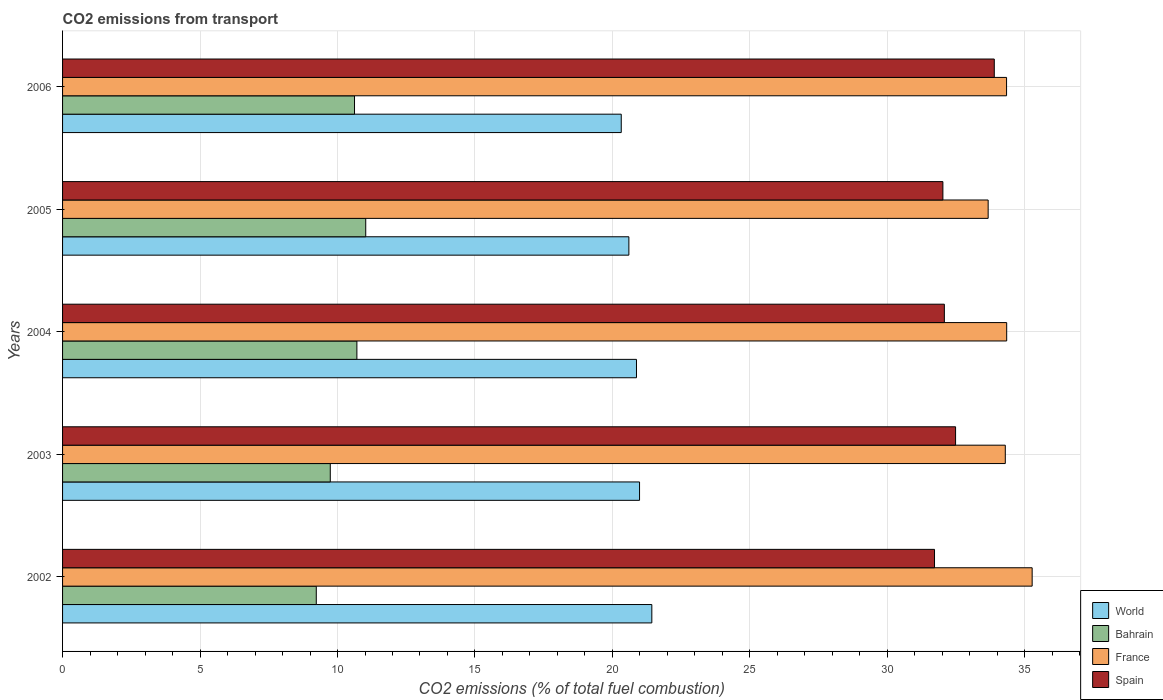How many different coloured bars are there?
Keep it short and to the point. 4. Are the number of bars per tick equal to the number of legend labels?
Make the answer very short. Yes. Are the number of bars on each tick of the Y-axis equal?
Offer a terse response. Yes. How many bars are there on the 2nd tick from the bottom?
Ensure brevity in your answer.  4. What is the total CO2 emitted in World in 2002?
Give a very brief answer. 21.43. Across all years, what is the maximum total CO2 emitted in France?
Offer a very short reply. 35.27. Across all years, what is the minimum total CO2 emitted in Spain?
Provide a short and direct response. 31.71. In which year was the total CO2 emitted in World minimum?
Provide a succinct answer. 2006. What is the total total CO2 emitted in Spain in the graph?
Provide a short and direct response. 162.18. What is the difference between the total CO2 emitted in World in 2004 and that in 2005?
Your answer should be compact. 0.28. What is the difference between the total CO2 emitted in Bahrain in 2006 and the total CO2 emitted in France in 2003?
Your answer should be compact. -23.67. What is the average total CO2 emitted in World per year?
Offer a terse response. 20.84. In the year 2003, what is the difference between the total CO2 emitted in World and total CO2 emitted in Spain?
Make the answer very short. -11.49. In how many years, is the total CO2 emitted in Spain greater than 14 ?
Give a very brief answer. 5. What is the ratio of the total CO2 emitted in Spain in 2002 to that in 2003?
Provide a succinct answer. 0.98. Is the difference between the total CO2 emitted in World in 2002 and 2006 greater than the difference between the total CO2 emitted in Spain in 2002 and 2006?
Offer a terse response. Yes. What is the difference between the highest and the second highest total CO2 emitted in France?
Give a very brief answer. 0.93. What is the difference between the highest and the lowest total CO2 emitted in Spain?
Your answer should be compact. 2.17. In how many years, is the total CO2 emitted in Bahrain greater than the average total CO2 emitted in Bahrain taken over all years?
Ensure brevity in your answer.  3. Is it the case that in every year, the sum of the total CO2 emitted in France and total CO2 emitted in Bahrain is greater than the sum of total CO2 emitted in Spain and total CO2 emitted in World?
Your answer should be very brief. No. What does the 4th bar from the top in 2006 represents?
Offer a very short reply. World. What does the 4th bar from the bottom in 2003 represents?
Your response must be concise. Spain. How many bars are there?
Make the answer very short. 20. How many years are there in the graph?
Provide a succinct answer. 5. What is the difference between two consecutive major ticks on the X-axis?
Provide a short and direct response. 5. Does the graph contain grids?
Your answer should be compact. Yes. How many legend labels are there?
Your answer should be very brief. 4. How are the legend labels stacked?
Provide a short and direct response. Vertical. What is the title of the graph?
Offer a very short reply. CO2 emissions from transport. What is the label or title of the X-axis?
Offer a terse response. CO2 emissions (% of total fuel combustion). What is the label or title of the Y-axis?
Make the answer very short. Years. What is the CO2 emissions (% of total fuel combustion) of World in 2002?
Your response must be concise. 21.43. What is the CO2 emissions (% of total fuel combustion) of Bahrain in 2002?
Your answer should be compact. 9.23. What is the CO2 emissions (% of total fuel combustion) in France in 2002?
Your answer should be very brief. 35.27. What is the CO2 emissions (% of total fuel combustion) of Spain in 2002?
Provide a short and direct response. 31.71. What is the CO2 emissions (% of total fuel combustion) in World in 2003?
Offer a very short reply. 20.99. What is the CO2 emissions (% of total fuel combustion) in Bahrain in 2003?
Your answer should be very brief. 9.74. What is the CO2 emissions (% of total fuel combustion) of France in 2003?
Offer a terse response. 34.29. What is the CO2 emissions (% of total fuel combustion) in Spain in 2003?
Keep it short and to the point. 32.48. What is the CO2 emissions (% of total fuel combustion) in World in 2004?
Offer a terse response. 20.87. What is the CO2 emissions (% of total fuel combustion) in Bahrain in 2004?
Your response must be concise. 10.71. What is the CO2 emissions (% of total fuel combustion) in France in 2004?
Your response must be concise. 34.34. What is the CO2 emissions (% of total fuel combustion) of Spain in 2004?
Provide a short and direct response. 32.07. What is the CO2 emissions (% of total fuel combustion) of World in 2005?
Make the answer very short. 20.6. What is the CO2 emissions (% of total fuel combustion) of Bahrain in 2005?
Ensure brevity in your answer.  11.03. What is the CO2 emissions (% of total fuel combustion) in France in 2005?
Provide a short and direct response. 33.67. What is the CO2 emissions (% of total fuel combustion) in Spain in 2005?
Make the answer very short. 32.02. What is the CO2 emissions (% of total fuel combustion) in World in 2006?
Your answer should be compact. 20.32. What is the CO2 emissions (% of total fuel combustion) of Bahrain in 2006?
Your response must be concise. 10.62. What is the CO2 emissions (% of total fuel combustion) in France in 2006?
Provide a succinct answer. 34.34. What is the CO2 emissions (% of total fuel combustion) of Spain in 2006?
Ensure brevity in your answer.  33.89. Across all years, what is the maximum CO2 emissions (% of total fuel combustion) in World?
Ensure brevity in your answer.  21.43. Across all years, what is the maximum CO2 emissions (% of total fuel combustion) of Bahrain?
Offer a terse response. 11.03. Across all years, what is the maximum CO2 emissions (% of total fuel combustion) in France?
Make the answer very short. 35.27. Across all years, what is the maximum CO2 emissions (% of total fuel combustion) of Spain?
Provide a short and direct response. 33.89. Across all years, what is the minimum CO2 emissions (% of total fuel combustion) of World?
Make the answer very short. 20.32. Across all years, what is the minimum CO2 emissions (% of total fuel combustion) of Bahrain?
Your answer should be very brief. 9.23. Across all years, what is the minimum CO2 emissions (% of total fuel combustion) in France?
Make the answer very short. 33.67. Across all years, what is the minimum CO2 emissions (% of total fuel combustion) in Spain?
Your response must be concise. 31.71. What is the total CO2 emissions (% of total fuel combustion) of World in the graph?
Your answer should be very brief. 104.21. What is the total CO2 emissions (% of total fuel combustion) in Bahrain in the graph?
Make the answer very short. 51.32. What is the total CO2 emissions (% of total fuel combustion) in France in the graph?
Make the answer very short. 171.9. What is the total CO2 emissions (% of total fuel combustion) of Spain in the graph?
Give a very brief answer. 162.18. What is the difference between the CO2 emissions (% of total fuel combustion) of World in 2002 and that in 2003?
Provide a short and direct response. 0.45. What is the difference between the CO2 emissions (% of total fuel combustion) of Bahrain in 2002 and that in 2003?
Keep it short and to the point. -0.51. What is the difference between the CO2 emissions (% of total fuel combustion) in France in 2002 and that in 2003?
Offer a very short reply. 0.98. What is the difference between the CO2 emissions (% of total fuel combustion) of Spain in 2002 and that in 2003?
Make the answer very short. -0.77. What is the difference between the CO2 emissions (% of total fuel combustion) of World in 2002 and that in 2004?
Give a very brief answer. 0.56. What is the difference between the CO2 emissions (% of total fuel combustion) of Bahrain in 2002 and that in 2004?
Provide a succinct answer. -1.48. What is the difference between the CO2 emissions (% of total fuel combustion) of France in 2002 and that in 2004?
Your answer should be very brief. 0.93. What is the difference between the CO2 emissions (% of total fuel combustion) in Spain in 2002 and that in 2004?
Offer a terse response. -0.36. What is the difference between the CO2 emissions (% of total fuel combustion) in World in 2002 and that in 2005?
Provide a succinct answer. 0.83. What is the difference between the CO2 emissions (% of total fuel combustion) in Bahrain in 2002 and that in 2005?
Make the answer very short. -1.8. What is the difference between the CO2 emissions (% of total fuel combustion) in France in 2002 and that in 2005?
Offer a terse response. 1.6. What is the difference between the CO2 emissions (% of total fuel combustion) of Spain in 2002 and that in 2005?
Keep it short and to the point. -0.3. What is the difference between the CO2 emissions (% of total fuel combustion) in World in 2002 and that in 2006?
Provide a short and direct response. 1.11. What is the difference between the CO2 emissions (% of total fuel combustion) in Bahrain in 2002 and that in 2006?
Offer a terse response. -1.39. What is the difference between the CO2 emissions (% of total fuel combustion) in France in 2002 and that in 2006?
Provide a succinct answer. 0.93. What is the difference between the CO2 emissions (% of total fuel combustion) of Spain in 2002 and that in 2006?
Provide a short and direct response. -2.17. What is the difference between the CO2 emissions (% of total fuel combustion) in World in 2003 and that in 2004?
Give a very brief answer. 0.11. What is the difference between the CO2 emissions (% of total fuel combustion) in Bahrain in 2003 and that in 2004?
Keep it short and to the point. -0.97. What is the difference between the CO2 emissions (% of total fuel combustion) in France in 2003 and that in 2004?
Offer a terse response. -0.05. What is the difference between the CO2 emissions (% of total fuel combustion) in Spain in 2003 and that in 2004?
Provide a short and direct response. 0.41. What is the difference between the CO2 emissions (% of total fuel combustion) of World in 2003 and that in 2005?
Provide a succinct answer. 0.39. What is the difference between the CO2 emissions (% of total fuel combustion) of Bahrain in 2003 and that in 2005?
Provide a succinct answer. -1.29. What is the difference between the CO2 emissions (% of total fuel combustion) in France in 2003 and that in 2005?
Offer a very short reply. 0.62. What is the difference between the CO2 emissions (% of total fuel combustion) of Spain in 2003 and that in 2005?
Keep it short and to the point. 0.46. What is the difference between the CO2 emissions (% of total fuel combustion) of World in 2003 and that in 2006?
Your answer should be compact. 0.67. What is the difference between the CO2 emissions (% of total fuel combustion) in Bahrain in 2003 and that in 2006?
Ensure brevity in your answer.  -0.88. What is the difference between the CO2 emissions (% of total fuel combustion) in France in 2003 and that in 2006?
Make the answer very short. -0.05. What is the difference between the CO2 emissions (% of total fuel combustion) in Spain in 2003 and that in 2006?
Give a very brief answer. -1.41. What is the difference between the CO2 emissions (% of total fuel combustion) in World in 2004 and that in 2005?
Offer a very short reply. 0.28. What is the difference between the CO2 emissions (% of total fuel combustion) of Bahrain in 2004 and that in 2005?
Ensure brevity in your answer.  -0.32. What is the difference between the CO2 emissions (% of total fuel combustion) of France in 2004 and that in 2005?
Provide a short and direct response. 0.67. What is the difference between the CO2 emissions (% of total fuel combustion) in Spain in 2004 and that in 2005?
Your answer should be compact. 0.05. What is the difference between the CO2 emissions (% of total fuel combustion) of World in 2004 and that in 2006?
Provide a succinct answer. 0.55. What is the difference between the CO2 emissions (% of total fuel combustion) in Bahrain in 2004 and that in 2006?
Keep it short and to the point. 0.09. What is the difference between the CO2 emissions (% of total fuel combustion) in France in 2004 and that in 2006?
Ensure brevity in your answer.  0. What is the difference between the CO2 emissions (% of total fuel combustion) in Spain in 2004 and that in 2006?
Ensure brevity in your answer.  -1.82. What is the difference between the CO2 emissions (% of total fuel combustion) in World in 2005 and that in 2006?
Make the answer very short. 0.28. What is the difference between the CO2 emissions (% of total fuel combustion) of Bahrain in 2005 and that in 2006?
Offer a very short reply. 0.41. What is the difference between the CO2 emissions (% of total fuel combustion) in France in 2005 and that in 2006?
Your response must be concise. -0.67. What is the difference between the CO2 emissions (% of total fuel combustion) of Spain in 2005 and that in 2006?
Keep it short and to the point. -1.87. What is the difference between the CO2 emissions (% of total fuel combustion) of World in 2002 and the CO2 emissions (% of total fuel combustion) of Bahrain in 2003?
Offer a very short reply. 11.7. What is the difference between the CO2 emissions (% of total fuel combustion) in World in 2002 and the CO2 emissions (% of total fuel combustion) in France in 2003?
Ensure brevity in your answer.  -12.86. What is the difference between the CO2 emissions (% of total fuel combustion) in World in 2002 and the CO2 emissions (% of total fuel combustion) in Spain in 2003?
Your answer should be very brief. -11.05. What is the difference between the CO2 emissions (% of total fuel combustion) in Bahrain in 2002 and the CO2 emissions (% of total fuel combustion) in France in 2003?
Provide a succinct answer. -25.06. What is the difference between the CO2 emissions (% of total fuel combustion) of Bahrain in 2002 and the CO2 emissions (% of total fuel combustion) of Spain in 2003?
Provide a succinct answer. -23.25. What is the difference between the CO2 emissions (% of total fuel combustion) in France in 2002 and the CO2 emissions (% of total fuel combustion) in Spain in 2003?
Provide a succinct answer. 2.79. What is the difference between the CO2 emissions (% of total fuel combustion) of World in 2002 and the CO2 emissions (% of total fuel combustion) of Bahrain in 2004?
Provide a short and direct response. 10.73. What is the difference between the CO2 emissions (% of total fuel combustion) of World in 2002 and the CO2 emissions (% of total fuel combustion) of France in 2004?
Offer a very short reply. -12.91. What is the difference between the CO2 emissions (% of total fuel combustion) of World in 2002 and the CO2 emissions (% of total fuel combustion) of Spain in 2004?
Your response must be concise. -10.64. What is the difference between the CO2 emissions (% of total fuel combustion) in Bahrain in 2002 and the CO2 emissions (% of total fuel combustion) in France in 2004?
Make the answer very short. -25.11. What is the difference between the CO2 emissions (% of total fuel combustion) of Bahrain in 2002 and the CO2 emissions (% of total fuel combustion) of Spain in 2004?
Make the answer very short. -22.84. What is the difference between the CO2 emissions (% of total fuel combustion) of France in 2002 and the CO2 emissions (% of total fuel combustion) of Spain in 2004?
Provide a short and direct response. 3.19. What is the difference between the CO2 emissions (% of total fuel combustion) in World in 2002 and the CO2 emissions (% of total fuel combustion) in Bahrain in 2005?
Give a very brief answer. 10.41. What is the difference between the CO2 emissions (% of total fuel combustion) in World in 2002 and the CO2 emissions (% of total fuel combustion) in France in 2005?
Provide a succinct answer. -12.23. What is the difference between the CO2 emissions (% of total fuel combustion) in World in 2002 and the CO2 emissions (% of total fuel combustion) in Spain in 2005?
Make the answer very short. -10.59. What is the difference between the CO2 emissions (% of total fuel combustion) of Bahrain in 2002 and the CO2 emissions (% of total fuel combustion) of France in 2005?
Offer a terse response. -24.44. What is the difference between the CO2 emissions (% of total fuel combustion) in Bahrain in 2002 and the CO2 emissions (% of total fuel combustion) in Spain in 2005?
Keep it short and to the point. -22.79. What is the difference between the CO2 emissions (% of total fuel combustion) of France in 2002 and the CO2 emissions (% of total fuel combustion) of Spain in 2005?
Provide a succinct answer. 3.25. What is the difference between the CO2 emissions (% of total fuel combustion) of World in 2002 and the CO2 emissions (% of total fuel combustion) of Bahrain in 2006?
Provide a succinct answer. 10.81. What is the difference between the CO2 emissions (% of total fuel combustion) in World in 2002 and the CO2 emissions (% of total fuel combustion) in France in 2006?
Give a very brief answer. -12.9. What is the difference between the CO2 emissions (% of total fuel combustion) of World in 2002 and the CO2 emissions (% of total fuel combustion) of Spain in 2006?
Your response must be concise. -12.46. What is the difference between the CO2 emissions (% of total fuel combustion) of Bahrain in 2002 and the CO2 emissions (% of total fuel combustion) of France in 2006?
Provide a succinct answer. -25.11. What is the difference between the CO2 emissions (% of total fuel combustion) of Bahrain in 2002 and the CO2 emissions (% of total fuel combustion) of Spain in 2006?
Make the answer very short. -24.66. What is the difference between the CO2 emissions (% of total fuel combustion) of France in 2002 and the CO2 emissions (% of total fuel combustion) of Spain in 2006?
Provide a short and direct response. 1.38. What is the difference between the CO2 emissions (% of total fuel combustion) in World in 2003 and the CO2 emissions (% of total fuel combustion) in Bahrain in 2004?
Your answer should be very brief. 10.28. What is the difference between the CO2 emissions (% of total fuel combustion) in World in 2003 and the CO2 emissions (% of total fuel combustion) in France in 2004?
Your response must be concise. -13.35. What is the difference between the CO2 emissions (% of total fuel combustion) of World in 2003 and the CO2 emissions (% of total fuel combustion) of Spain in 2004?
Ensure brevity in your answer.  -11.09. What is the difference between the CO2 emissions (% of total fuel combustion) of Bahrain in 2003 and the CO2 emissions (% of total fuel combustion) of France in 2004?
Your answer should be very brief. -24.6. What is the difference between the CO2 emissions (% of total fuel combustion) in Bahrain in 2003 and the CO2 emissions (% of total fuel combustion) in Spain in 2004?
Ensure brevity in your answer.  -22.33. What is the difference between the CO2 emissions (% of total fuel combustion) of France in 2003 and the CO2 emissions (% of total fuel combustion) of Spain in 2004?
Your answer should be very brief. 2.22. What is the difference between the CO2 emissions (% of total fuel combustion) of World in 2003 and the CO2 emissions (% of total fuel combustion) of Bahrain in 2005?
Give a very brief answer. 9.96. What is the difference between the CO2 emissions (% of total fuel combustion) in World in 2003 and the CO2 emissions (% of total fuel combustion) in France in 2005?
Offer a very short reply. -12.68. What is the difference between the CO2 emissions (% of total fuel combustion) in World in 2003 and the CO2 emissions (% of total fuel combustion) in Spain in 2005?
Keep it short and to the point. -11.03. What is the difference between the CO2 emissions (% of total fuel combustion) in Bahrain in 2003 and the CO2 emissions (% of total fuel combustion) in France in 2005?
Make the answer very short. -23.93. What is the difference between the CO2 emissions (% of total fuel combustion) in Bahrain in 2003 and the CO2 emissions (% of total fuel combustion) in Spain in 2005?
Offer a very short reply. -22.28. What is the difference between the CO2 emissions (% of total fuel combustion) in France in 2003 and the CO2 emissions (% of total fuel combustion) in Spain in 2005?
Keep it short and to the point. 2.27. What is the difference between the CO2 emissions (% of total fuel combustion) in World in 2003 and the CO2 emissions (% of total fuel combustion) in Bahrain in 2006?
Offer a very short reply. 10.37. What is the difference between the CO2 emissions (% of total fuel combustion) in World in 2003 and the CO2 emissions (% of total fuel combustion) in France in 2006?
Offer a terse response. -13.35. What is the difference between the CO2 emissions (% of total fuel combustion) in World in 2003 and the CO2 emissions (% of total fuel combustion) in Spain in 2006?
Your response must be concise. -12.9. What is the difference between the CO2 emissions (% of total fuel combustion) in Bahrain in 2003 and the CO2 emissions (% of total fuel combustion) in France in 2006?
Your response must be concise. -24.6. What is the difference between the CO2 emissions (% of total fuel combustion) in Bahrain in 2003 and the CO2 emissions (% of total fuel combustion) in Spain in 2006?
Make the answer very short. -24.15. What is the difference between the CO2 emissions (% of total fuel combustion) of France in 2003 and the CO2 emissions (% of total fuel combustion) of Spain in 2006?
Keep it short and to the point. 0.4. What is the difference between the CO2 emissions (% of total fuel combustion) of World in 2004 and the CO2 emissions (% of total fuel combustion) of Bahrain in 2005?
Provide a succinct answer. 9.85. What is the difference between the CO2 emissions (% of total fuel combustion) of World in 2004 and the CO2 emissions (% of total fuel combustion) of France in 2005?
Your answer should be compact. -12.79. What is the difference between the CO2 emissions (% of total fuel combustion) of World in 2004 and the CO2 emissions (% of total fuel combustion) of Spain in 2005?
Give a very brief answer. -11.14. What is the difference between the CO2 emissions (% of total fuel combustion) in Bahrain in 2004 and the CO2 emissions (% of total fuel combustion) in France in 2005?
Give a very brief answer. -22.96. What is the difference between the CO2 emissions (% of total fuel combustion) in Bahrain in 2004 and the CO2 emissions (% of total fuel combustion) in Spain in 2005?
Offer a very short reply. -21.31. What is the difference between the CO2 emissions (% of total fuel combustion) of France in 2004 and the CO2 emissions (% of total fuel combustion) of Spain in 2005?
Make the answer very short. 2.32. What is the difference between the CO2 emissions (% of total fuel combustion) of World in 2004 and the CO2 emissions (% of total fuel combustion) of Bahrain in 2006?
Your answer should be very brief. 10.26. What is the difference between the CO2 emissions (% of total fuel combustion) in World in 2004 and the CO2 emissions (% of total fuel combustion) in France in 2006?
Your response must be concise. -13.46. What is the difference between the CO2 emissions (% of total fuel combustion) of World in 2004 and the CO2 emissions (% of total fuel combustion) of Spain in 2006?
Provide a succinct answer. -13.01. What is the difference between the CO2 emissions (% of total fuel combustion) of Bahrain in 2004 and the CO2 emissions (% of total fuel combustion) of France in 2006?
Your response must be concise. -23.63. What is the difference between the CO2 emissions (% of total fuel combustion) in Bahrain in 2004 and the CO2 emissions (% of total fuel combustion) in Spain in 2006?
Offer a very short reply. -23.18. What is the difference between the CO2 emissions (% of total fuel combustion) of France in 2004 and the CO2 emissions (% of total fuel combustion) of Spain in 2006?
Your answer should be very brief. 0.45. What is the difference between the CO2 emissions (% of total fuel combustion) of World in 2005 and the CO2 emissions (% of total fuel combustion) of Bahrain in 2006?
Your response must be concise. 9.98. What is the difference between the CO2 emissions (% of total fuel combustion) in World in 2005 and the CO2 emissions (% of total fuel combustion) in France in 2006?
Provide a short and direct response. -13.74. What is the difference between the CO2 emissions (% of total fuel combustion) in World in 2005 and the CO2 emissions (% of total fuel combustion) in Spain in 2006?
Your answer should be compact. -13.29. What is the difference between the CO2 emissions (% of total fuel combustion) of Bahrain in 2005 and the CO2 emissions (% of total fuel combustion) of France in 2006?
Give a very brief answer. -23.31. What is the difference between the CO2 emissions (% of total fuel combustion) of Bahrain in 2005 and the CO2 emissions (% of total fuel combustion) of Spain in 2006?
Offer a very short reply. -22.86. What is the difference between the CO2 emissions (% of total fuel combustion) of France in 2005 and the CO2 emissions (% of total fuel combustion) of Spain in 2006?
Make the answer very short. -0.22. What is the average CO2 emissions (% of total fuel combustion) in World per year?
Ensure brevity in your answer.  20.84. What is the average CO2 emissions (% of total fuel combustion) in Bahrain per year?
Provide a short and direct response. 10.26. What is the average CO2 emissions (% of total fuel combustion) in France per year?
Provide a short and direct response. 34.38. What is the average CO2 emissions (% of total fuel combustion) of Spain per year?
Your answer should be compact. 32.44. In the year 2002, what is the difference between the CO2 emissions (% of total fuel combustion) of World and CO2 emissions (% of total fuel combustion) of Bahrain?
Give a very brief answer. 12.2. In the year 2002, what is the difference between the CO2 emissions (% of total fuel combustion) in World and CO2 emissions (% of total fuel combustion) in France?
Keep it short and to the point. -13.83. In the year 2002, what is the difference between the CO2 emissions (% of total fuel combustion) of World and CO2 emissions (% of total fuel combustion) of Spain?
Keep it short and to the point. -10.28. In the year 2002, what is the difference between the CO2 emissions (% of total fuel combustion) in Bahrain and CO2 emissions (% of total fuel combustion) in France?
Keep it short and to the point. -26.04. In the year 2002, what is the difference between the CO2 emissions (% of total fuel combustion) in Bahrain and CO2 emissions (% of total fuel combustion) in Spain?
Ensure brevity in your answer.  -22.49. In the year 2002, what is the difference between the CO2 emissions (% of total fuel combustion) in France and CO2 emissions (% of total fuel combustion) in Spain?
Provide a succinct answer. 3.55. In the year 2003, what is the difference between the CO2 emissions (% of total fuel combustion) in World and CO2 emissions (% of total fuel combustion) in Bahrain?
Keep it short and to the point. 11.25. In the year 2003, what is the difference between the CO2 emissions (% of total fuel combustion) in World and CO2 emissions (% of total fuel combustion) in France?
Your answer should be compact. -13.3. In the year 2003, what is the difference between the CO2 emissions (% of total fuel combustion) in World and CO2 emissions (% of total fuel combustion) in Spain?
Make the answer very short. -11.49. In the year 2003, what is the difference between the CO2 emissions (% of total fuel combustion) in Bahrain and CO2 emissions (% of total fuel combustion) in France?
Give a very brief answer. -24.55. In the year 2003, what is the difference between the CO2 emissions (% of total fuel combustion) of Bahrain and CO2 emissions (% of total fuel combustion) of Spain?
Ensure brevity in your answer.  -22.74. In the year 2003, what is the difference between the CO2 emissions (% of total fuel combustion) in France and CO2 emissions (% of total fuel combustion) in Spain?
Provide a short and direct response. 1.81. In the year 2004, what is the difference between the CO2 emissions (% of total fuel combustion) in World and CO2 emissions (% of total fuel combustion) in Bahrain?
Keep it short and to the point. 10.17. In the year 2004, what is the difference between the CO2 emissions (% of total fuel combustion) of World and CO2 emissions (% of total fuel combustion) of France?
Your answer should be very brief. -13.47. In the year 2004, what is the difference between the CO2 emissions (% of total fuel combustion) in World and CO2 emissions (% of total fuel combustion) in Spain?
Provide a short and direct response. -11.2. In the year 2004, what is the difference between the CO2 emissions (% of total fuel combustion) of Bahrain and CO2 emissions (% of total fuel combustion) of France?
Ensure brevity in your answer.  -23.63. In the year 2004, what is the difference between the CO2 emissions (% of total fuel combustion) in Bahrain and CO2 emissions (% of total fuel combustion) in Spain?
Give a very brief answer. -21.37. In the year 2004, what is the difference between the CO2 emissions (% of total fuel combustion) of France and CO2 emissions (% of total fuel combustion) of Spain?
Keep it short and to the point. 2.27. In the year 2005, what is the difference between the CO2 emissions (% of total fuel combustion) in World and CO2 emissions (% of total fuel combustion) in Bahrain?
Make the answer very short. 9.57. In the year 2005, what is the difference between the CO2 emissions (% of total fuel combustion) of World and CO2 emissions (% of total fuel combustion) of France?
Your answer should be very brief. -13.07. In the year 2005, what is the difference between the CO2 emissions (% of total fuel combustion) in World and CO2 emissions (% of total fuel combustion) in Spain?
Ensure brevity in your answer.  -11.42. In the year 2005, what is the difference between the CO2 emissions (% of total fuel combustion) of Bahrain and CO2 emissions (% of total fuel combustion) of France?
Offer a terse response. -22.64. In the year 2005, what is the difference between the CO2 emissions (% of total fuel combustion) of Bahrain and CO2 emissions (% of total fuel combustion) of Spain?
Keep it short and to the point. -20.99. In the year 2005, what is the difference between the CO2 emissions (% of total fuel combustion) in France and CO2 emissions (% of total fuel combustion) in Spain?
Provide a short and direct response. 1.65. In the year 2006, what is the difference between the CO2 emissions (% of total fuel combustion) of World and CO2 emissions (% of total fuel combustion) of Bahrain?
Provide a succinct answer. 9.7. In the year 2006, what is the difference between the CO2 emissions (% of total fuel combustion) of World and CO2 emissions (% of total fuel combustion) of France?
Your answer should be very brief. -14.01. In the year 2006, what is the difference between the CO2 emissions (% of total fuel combustion) of World and CO2 emissions (% of total fuel combustion) of Spain?
Your answer should be very brief. -13.57. In the year 2006, what is the difference between the CO2 emissions (% of total fuel combustion) in Bahrain and CO2 emissions (% of total fuel combustion) in France?
Keep it short and to the point. -23.72. In the year 2006, what is the difference between the CO2 emissions (% of total fuel combustion) in Bahrain and CO2 emissions (% of total fuel combustion) in Spain?
Ensure brevity in your answer.  -23.27. In the year 2006, what is the difference between the CO2 emissions (% of total fuel combustion) of France and CO2 emissions (% of total fuel combustion) of Spain?
Your answer should be very brief. 0.45. What is the ratio of the CO2 emissions (% of total fuel combustion) of World in 2002 to that in 2003?
Provide a short and direct response. 1.02. What is the ratio of the CO2 emissions (% of total fuel combustion) in Bahrain in 2002 to that in 2003?
Offer a terse response. 0.95. What is the ratio of the CO2 emissions (% of total fuel combustion) in France in 2002 to that in 2003?
Your answer should be compact. 1.03. What is the ratio of the CO2 emissions (% of total fuel combustion) in Spain in 2002 to that in 2003?
Make the answer very short. 0.98. What is the ratio of the CO2 emissions (% of total fuel combustion) of World in 2002 to that in 2004?
Ensure brevity in your answer.  1.03. What is the ratio of the CO2 emissions (% of total fuel combustion) of Bahrain in 2002 to that in 2004?
Keep it short and to the point. 0.86. What is the ratio of the CO2 emissions (% of total fuel combustion) in World in 2002 to that in 2005?
Ensure brevity in your answer.  1.04. What is the ratio of the CO2 emissions (% of total fuel combustion) of Bahrain in 2002 to that in 2005?
Give a very brief answer. 0.84. What is the ratio of the CO2 emissions (% of total fuel combustion) in France in 2002 to that in 2005?
Your response must be concise. 1.05. What is the ratio of the CO2 emissions (% of total fuel combustion) in World in 2002 to that in 2006?
Your response must be concise. 1.05. What is the ratio of the CO2 emissions (% of total fuel combustion) in Bahrain in 2002 to that in 2006?
Offer a very short reply. 0.87. What is the ratio of the CO2 emissions (% of total fuel combustion) in France in 2002 to that in 2006?
Ensure brevity in your answer.  1.03. What is the ratio of the CO2 emissions (% of total fuel combustion) in Spain in 2002 to that in 2006?
Make the answer very short. 0.94. What is the ratio of the CO2 emissions (% of total fuel combustion) of Bahrain in 2003 to that in 2004?
Offer a terse response. 0.91. What is the ratio of the CO2 emissions (% of total fuel combustion) in France in 2003 to that in 2004?
Your answer should be very brief. 1. What is the ratio of the CO2 emissions (% of total fuel combustion) in Spain in 2003 to that in 2004?
Provide a succinct answer. 1.01. What is the ratio of the CO2 emissions (% of total fuel combustion) of World in 2003 to that in 2005?
Offer a terse response. 1.02. What is the ratio of the CO2 emissions (% of total fuel combustion) of Bahrain in 2003 to that in 2005?
Provide a succinct answer. 0.88. What is the ratio of the CO2 emissions (% of total fuel combustion) of France in 2003 to that in 2005?
Offer a terse response. 1.02. What is the ratio of the CO2 emissions (% of total fuel combustion) in Spain in 2003 to that in 2005?
Give a very brief answer. 1.01. What is the ratio of the CO2 emissions (% of total fuel combustion) of World in 2003 to that in 2006?
Ensure brevity in your answer.  1.03. What is the ratio of the CO2 emissions (% of total fuel combustion) in Bahrain in 2003 to that in 2006?
Your response must be concise. 0.92. What is the ratio of the CO2 emissions (% of total fuel combustion) in France in 2003 to that in 2006?
Provide a succinct answer. 1. What is the ratio of the CO2 emissions (% of total fuel combustion) in Spain in 2003 to that in 2006?
Make the answer very short. 0.96. What is the ratio of the CO2 emissions (% of total fuel combustion) in World in 2004 to that in 2005?
Your response must be concise. 1.01. What is the ratio of the CO2 emissions (% of total fuel combustion) of Bahrain in 2004 to that in 2005?
Make the answer very short. 0.97. What is the ratio of the CO2 emissions (% of total fuel combustion) in Spain in 2004 to that in 2005?
Provide a succinct answer. 1. What is the ratio of the CO2 emissions (% of total fuel combustion) in World in 2004 to that in 2006?
Your response must be concise. 1.03. What is the ratio of the CO2 emissions (% of total fuel combustion) of Bahrain in 2004 to that in 2006?
Your response must be concise. 1.01. What is the ratio of the CO2 emissions (% of total fuel combustion) of France in 2004 to that in 2006?
Keep it short and to the point. 1. What is the ratio of the CO2 emissions (% of total fuel combustion) of Spain in 2004 to that in 2006?
Your answer should be compact. 0.95. What is the ratio of the CO2 emissions (% of total fuel combustion) of World in 2005 to that in 2006?
Make the answer very short. 1.01. What is the ratio of the CO2 emissions (% of total fuel combustion) in Bahrain in 2005 to that in 2006?
Provide a short and direct response. 1.04. What is the ratio of the CO2 emissions (% of total fuel combustion) in France in 2005 to that in 2006?
Offer a terse response. 0.98. What is the ratio of the CO2 emissions (% of total fuel combustion) in Spain in 2005 to that in 2006?
Ensure brevity in your answer.  0.94. What is the difference between the highest and the second highest CO2 emissions (% of total fuel combustion) in World?
Offer a terse response. 0.45. What is the difference between the highest and the second highest CO2 emissions (% of total fuel combustion) of Bahrain?
Your answer should be compact. 0.32. What is the difference between the highest and the second highest CO2 emissions (% of total fuel combustion) in France?
Keep it short and to the point. 0.93. What is the difference between the highest and the second highest CO2 emissions (% of total fuel combustion) in Spain?
Offer a very short reply. 1.41. What is the difference between the highest and the lowest CO2 emissions (% of total fuel combustion) in World?
Give a very brief answer. 1.11. What is the difference between the highest and the lowest CO2 emissions (% of total fuel combustion) in Bahrain?
Offer a terse response. 1.8. What is the difference between the highest and the lowest CO2 emissions (% of total fuel combustion) of France?
Ensure brevity in your answer.  1.6. What is the difference between the highest and the lowest CO2 emissions (% of total fuel combustion) in Spain?
Keep it short and to the point. 2.17. 